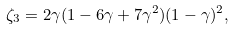Convert formula to latex. <formula><loc_0><loc_0><loc_500><loc_500>\zeta _ { 3 } = 2 \gamma ( 1 - 6 \gamma + 7 \gamma ^ { 2 } ) ( 1 - \gamma ) ^ { 2 } ,</formula> 